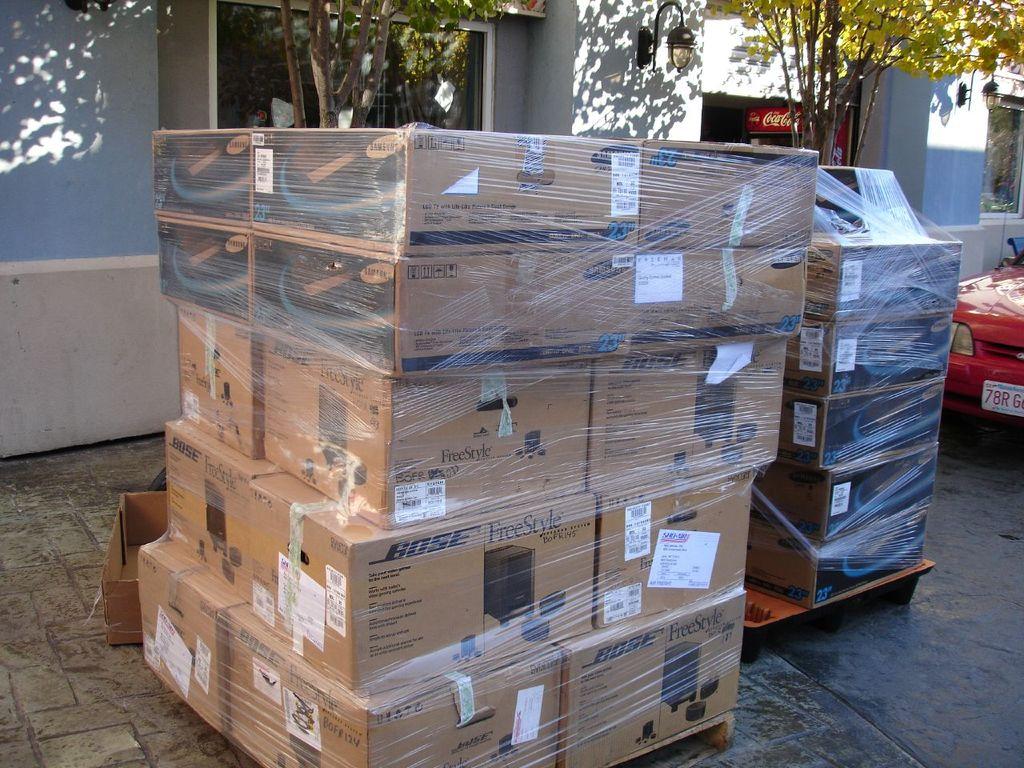What speaker company is on the boxes?
Your answer should be very brief. Bose. What is the name of the bose speaker style in these boxes?
Your answer should be compact. Freestyle. 